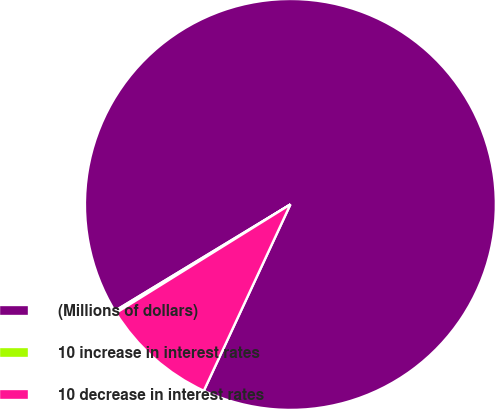Convert chart to OTSL. <chart><loc_0><loc_0><loc_500><loc_500><pie_chart><fcel>(Millions of dollars)<fcel>10 increase in interest rates<fcel>10 decrease in interest rates<nl><fcel>90.6%<fcel>0.18%<fcel>9.22%<nl></chart> 